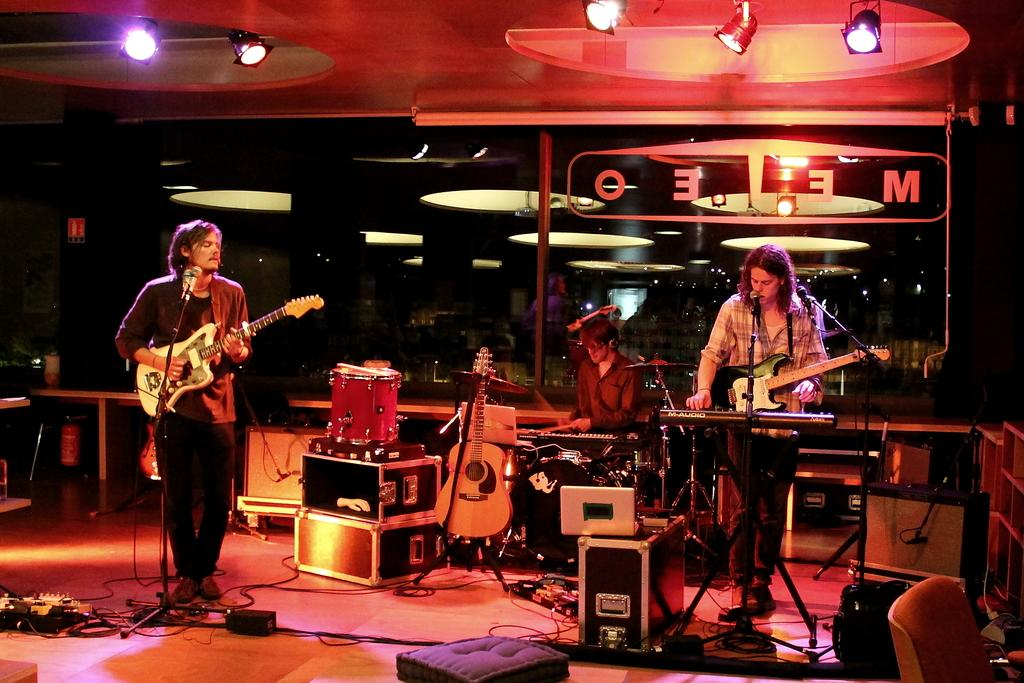How many people are in the image? There are three people in the image. What are two of the people doing? Two of the people are standing and holding guitars. What is the third person doing? One person is sitting. What other musical instruments can be seen in the image? There are additional musical instruments in the image. What objects are present that might be used for carrying or storing items? There are boxes in the image. What objects are present that might be used for amplifying sound or capturing audio? There are microphones (mics) in the image. What objects are present that might be used for illumination? There are lights in the image. What type of apple is being used as a drumstick in the image? There is no apple or drumstick present in the image. 